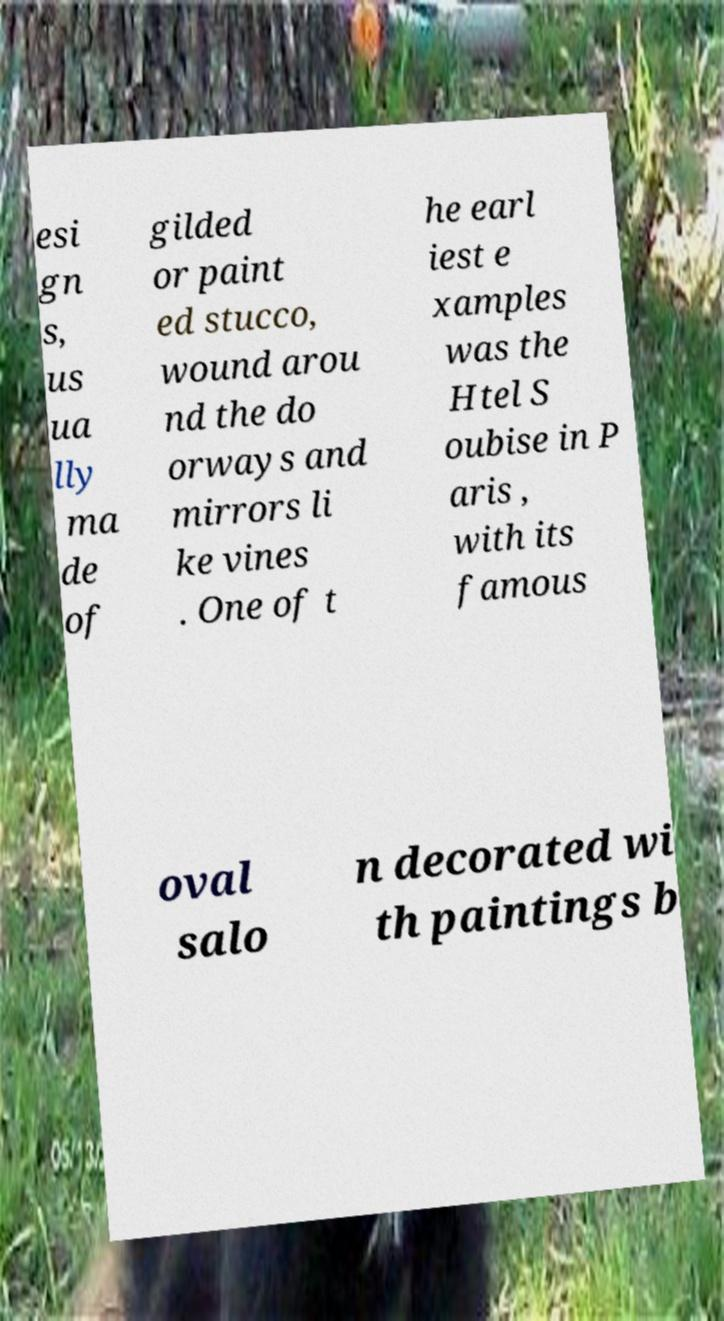Please read and relay the text visible in this image. What does it say? esi gn s, us ua lly ma de of gilded or paint ed stucco, wound arou nd the do orways and mirrors li ke vines . One of t he earl iest e xamples was the Htel S oubise in P aris , with its famous oval salo n decorated wi th paintings b 